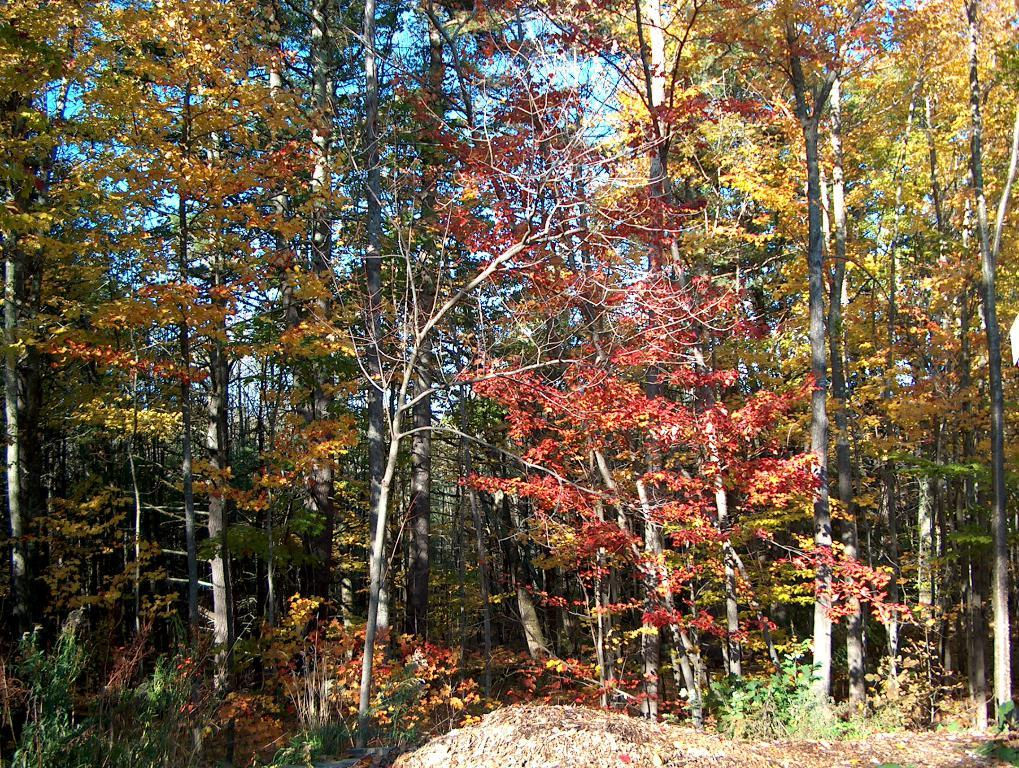What type of vegetation is present in the image? There are trees in the image. What colors can be seen on the leaves of the trees? The leaves of the trees have green, yellow, and red colors. What is on the ground in the image? There are leaves on the ground. What can be seen in the background of the image? The sky is visible in the background of the image. What type of drug is being sold by the bird in the image? There is no bird present in the image, and therefore no drug-related activity can be observed. 